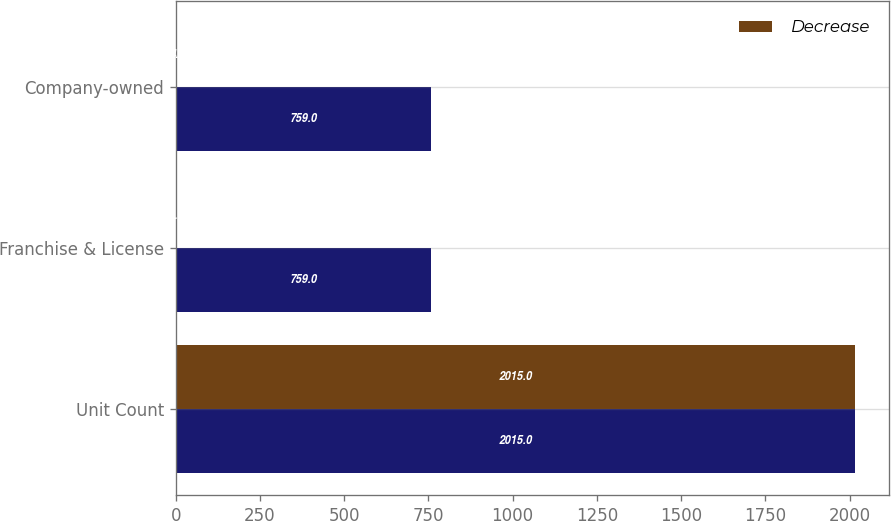Convert chart. <chart><loc_0><loc_0><loc_500><loc_500><stacked_bar_chart><ecel><fcel>Unit Count<fcel>Franchise & License<fcel>Company-owned<nl><fcel>nan<fcel>2015<fcel>759<fcel>759<nl><fcel>Decrease<fcel>2015<fcel>1<fcel>4<nl></chart> 